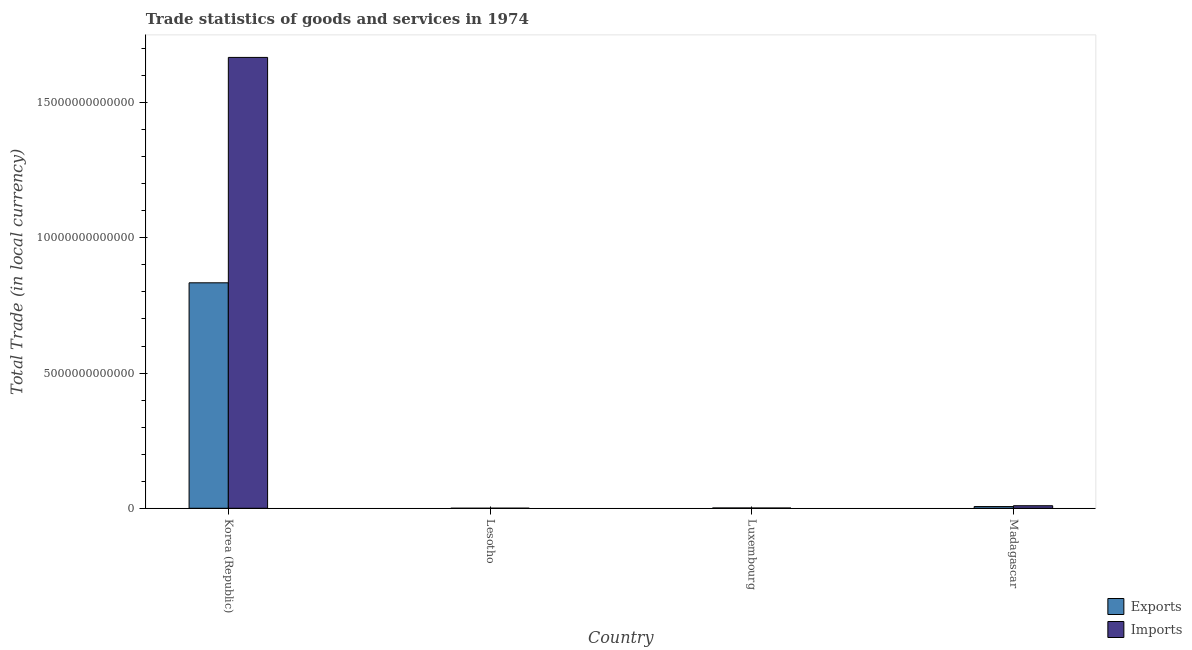How many different coloured bars are there?
Your response must be concise. 2. How many groups of bars are there?
Offer a very short reply. 4. Are the number of bars per tick equal to the number of legend labels?
Make the answer very short. Yes. How many bars are there on the 3rd tick from the left?
Provide a short and direct response. 2. What is the label of the 2nd group of bars from the left?
Provide a short and direct response. Lesotho. In how many cases, is the number of bars for a given country not equal to the number of legend labels?
Keep it short and to the point. 0. What is the export of goods and services in Korea (Republic)?
Offer a terse response. 8.34e+12. Across all countries, what is the maximum export of goods and services?
Offer a very short reply. 8.34e+12. Across all countries, what is the minimum export of goods and services?
Your answer should be very brief. 1.52e+08. In which country was the export of goods and services maximum?
Offer a terse response. Korea (Republic). In which country was the export of goods and services minimum?
Give a very brief answer. Lesotho. What is the total export of goods and services in the graph?
Keep it short and to the point. 8.41e+12. What is the difference between the export of goods and services in Korea (Republic) and that in Luxembourg?
Give a very brief answer. 8.33e+12. What is the difference between the imports of goods and services in Madagascar and the export of goods and services in Korea (Republic)?
Give a very brief answer. -8.24e+12. What is the average export of goods and services per country?
Your answer should be compact. 2.10e+12. What is the difference between the imports of goods and services and export of goods and services in Lesotho?
Provide a succinct answer. 2.83e+09. What is the ratio of the export of goods and services in Luxembourg to that in Madagascar?
Offer a terse response. 0.18. Is the difference between the imports of goods and services in Korea (Republic) and Madagascar greater than the difference between the export of goods and services in Korea (Republic) and Madagascar?
Provide a short and direct response. Yes. What is the difference between the highest and the second highest imports of goods and services?
Keep it short and to the point. 1.66e+13. What is the difference between the highest and the lowest imports of goods and services?
Offer a terse response. 1.67e+13. In how many countries, is the export of goods and services greater than the average export of goods and services taken over all countries?
Your response must be concise. 1. What does the 2nd bar from the left in Madagascar represents?
Your response must be concise. Imports. What does the 1st bar from the right in Madagascar represents?
Offer a very short reply. Imports. Are all the bars in the graph horizontal?
Offer a terse response. No. How many countries are there in the graph?
Your answer should be compact. 4. What is the difference between two consecutive major ticks on the Y-axis?
Offer a very short reply. 5.00e+12. Does the graph contain any zero values?
Provide a short and direct response. No. Does the graph contain grids?
Offer a very short reply. No. How are the legend labels stacked?
Keep it short and to the point. Vertical. What is the title of the graph?
Offer a very short reply. Trade statistics of goods and services in 1974. What is the label or title of the X-axis?
Your answer should be very brief. Country. What is the label or title of the Y-axis?
Offer a terse response. Total Trade (in local currency). What is the Total Trade (in local currency) of Exports in Korea (Republic)?
Provide a short and direct response. 8.34e+12. What is the Total Trade (in local currency) of Imports in Korea (Republic)?
Make the answer very short. 1.67e+13. What is the Total Trade (in local currency) of Exports in Lesotho?
Your answer should be very brief. 1.52e+08. What is the Total Trade (in local currency) in Imports in Lesotho?
Your answer should be very brief. 2.98e+09. What is the Total Trade (in local currency) of Exports in Luxembourg?
Your response must be concise. 1.15e+1. What is the Total Trade (in local currency) of Imports in Luxembourg?
Ensure brevity in your answer.  9.52e+09. What is the Total Trade (in local currency) of Exports in Madagascar?
Keep it short and to the point. 6.30e+1. What is the Total Trade (in local currency) in Imports in Madagascar?
Your answer should be very brief. 9.42e+1. Across all countries, what is the maximum Total Trade (in local currency) of Exports?
Make the answer very short. 8.34e+12. Across all countries, what is the maximum Total Trade (in local currency) of Imports?
Your answer should be very brief. 1.67e+13. Across all countries, what is the minimum Total Trade (in local currency) in Exports?
Provide a succinct answer. 1.52e+08. Across all countries, what is the minimum Total Trade (in local currency) of Imports?
Make the answer very short. 2.98e+09. What is the total Total Trade (in local currency) in Exports in the graph?
Your response must be concise. 8.41e+12. What is the total Total Trade (in local currency) in Imports in the graph?
Provide a short and direct response. 1.68e+13. What is the difference between the Total Trade (in local currency) in Exports in Korea (Republic) and that in Lesotho?
Keep it short and to the point. 8.34e+12. What is the difference between the Total Trade (in local currency) of Imports in Korea (Republic) and that in Lesotho?
Your answer should be very brief. 1.67e+13. What is the difference between the Total Trade (in local currency) of Exports in Korea (Republic) and that in Luxembourg?
Ensure brevity in your answer.  8.33e+12. What is the difference between the Total Trade (in local currency) of Imports in Korea (Republic) and that in Luxembourg?
Your answer should be compact. 1.67e+13. What is the difference between the Total Trade (in local currency) in Exports in Korea (Republic) and that in Madagascar?
Keep it short and to the point. 8.28e+12. What is the difference between the Total Trade (in local currency) of Imports in Korea (Republic) and that in Madagascar?
Your answer should be very brief. 1.66e+13. What is the difference between the Total Trade (in local currency) of Exports in Lesotho and that in Luxembourg?
Ensure brevity in your answer.  -1.13e+1. What is the difference between the Total Trade (in local currency) in Imports in Lesotho and that in Luxembourg?
Keep it short and to the point. -6.54e+09. What is the difference between the Total Trade (in local currency) in Exports in Lesotho and that in Madagascar?
Offer a very short reply. -6.29e+1. What is the difference between the Total Trade (in local currency) of Imports in Lesotho and that in Madagascar?
Offer a very short reply. -9.12e+1. What is the difference between the Total Trade (in local currency) of Exports in Luxembourg and that in Madagascar?
Ensure brevity in your answer.  -5.15e+1. What is the difference between the Total Trade (in local currency) of Imports in Luxembourg and that in Madagascar?
Offer a terse response. -8.47e+1. What is the difference between the Total Trade (in local currency) of Exports in Korea (Republic) and the Total Trade (in local currency) of Imports in Lesotho?
Provide a succinct answer. 8.34e+12. What is the difference between the Total Trade (in local currency) in Exports in Korea (Republic) and the Total Trade (in local currency) in Imports in Luxembourg?
Offer a very short reply. 8.33e+12. What is the difference between the Total Trade (in local currency) in Exports in Korea (Republic) and the Total Trade (in local currency) in Imports in Madagascar?
Give a very brief answer. 8.24e+12. What is the difference between the Total Trade (in local currency) of Exports in Lesotho and the Total Trade (in local currency) of Imports in Luxembourg?
Give a very brief answer. -9.37e+09. What is the difference between the Total Trade (in local currency) in Exports in Lesotho and the Total Trade (in local currency) in Imports in Madagascar?
Offer a very short reply. -9.40e+1. What is the difference between the Total Trade (in local currency) in Exports in Luxembourg and the Total Trade (in local currency) in Imports in Madagascar?
Your answer should be compact. -8.27e+1. What is the average Total Trade (in local currency) in Exports per country?
Offer a terse response. 2.10e+12. What is the average Total Trade (in local currency) of Imports per country?
Offer a very short reply. 4.20e+12. What is the difference between the Total Trade (in local currency) in Exports and Total Trade (in local currency) in Imports in Korea (Republic)?
Your answer should be very brief. -8.34e+12. What is the difference between the Total Trade (in local currency) of Exports and Total Trade (in local currency) of Imports in Lesotho?
Give a very brief answer. -2.83e+09. What is the difference between the Total Trade (in local currency) of Exports and Total Trade (in local currency) of Imports in Luxembourg?
Offer a terse response. 1.97e+09. What is the difference between the Total Trade (in local currency) of Exports and Total Trade (in local currency) of Imports in Madagascar?
Keep it short and to the point. -3.12e+1. What is the ratio of the Total Trade (in local currency) of Exports in Korea (Republic) to that in Lesotho?
Provide a succinct answer. 5.49e+04. What is the ratio of the Total Trade (in local currency) in Imports in Korea (Republic) to that in Lesotho?
Provide a succinct answer. 5598.2. What is the ratio of the Total Trade (in local currency) of Exports in Korea (Republic) to that in Luxembourg?
Offer a very short reply. 725.59. What is the ratio of the Total Trade (in local currency) in Imports in Korea (Republic) to that in Luxembourg?
Provide a short and direct response. 1751.32. What is the ratio of the Total Trade (in local currency) in Exports in Korea (Republic) to that in Madagascar?
Keep it short and to the point. 132.35. What is the ratio of the Total Trade (in local currency) in Imports in Korea (Republic) to that in Madagascar?
Offer a terse response. 177.04. What is the ratio of the Total Trade (in local currency) of Exports in Lesotho to that in Luxembourg?
Your response must be concise. 0.01. What is the ratio of the Total Trade (in local currency) of Imports in Lesotho to that in Luxembourg?
Offer a terse response. 0.31. What is the ratio of the Total Trade (in local currency) in Exports in Lesotho to that in Madagascar?
Your answer should be very brief. 0. What is the ratio of the Total Trade (in local currency) of Imports in Lesotho to that in Madagascar?
Your response must be concise. 0.03. What is the ratio of the Total Trade (in local currency) in Exports in Luxembourg to that in Madagascar?
Your answer should be very brief. 0.18. What is the ratio of the Total Trade (in local currency) of Imports in Luxembourg to that in Madagascar?
Offer a terse response. 0.1. What is the difference between the highest and the second highest Total Trade (in local currency) in Exports?
Offer a very short reply. 8.28e+12. What is the difference between the highest and the second highest Total Trade (in local currency) in Imports?
Ensure brevity in your answer.  1.66e+13. What is the difference between the highest and the lowest Total Trade (in local currency) in Exports?
Your answer should be very brief. 8.34e+12. What is the difference between the highest and the lowest Total Trade (in local currency) of Imports?
Provide a succinct answer. 1.67e+13. 